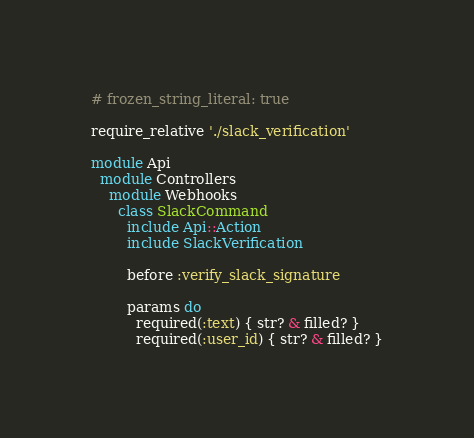<code> <loc_0><loc_0><loc_500><loc_500><_Ruby_># frozen_string_literal: true

require_relative './slack_verification'

module Api
  module Controllers
    module Webhooks
      class SlackCommand
        include Api::Action
        include SlackVerification

        before :verify_slack_signature

        params do
          required(:text) { str? & filled? }
          required(:user_id) { str? & filled? }</code> 